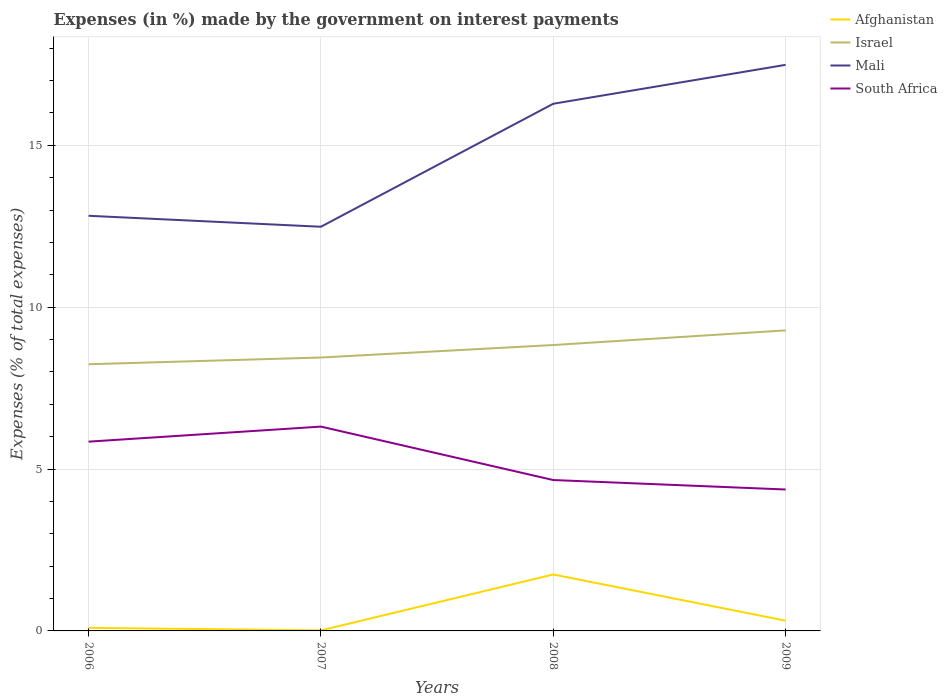Does the line corresponding to Mali intersect with the line corresponding to Israel?
Offer a terse response. No. Is the number of lines equal to the number of legend labels?
Provide a short and direct response. Yes. Across all years, what is the maximum percentage of expenses made by the government on interest payments in Afghanistan?
Offer a very short reply. 0.02. In which year was the percentage of expenses made by the government on interest payments in Israel maximum?
Your response must be concise. 2006. What is the total percentage of expenses made by the government on interest payments in South Africa in the graph?
Offer a terse response. 1.48. What is the difference between the highest and the second highest percentage of expenses made by the government on interest payments in South Africa?
Keep it short and to the point. 1.94. What is the difference between the highest and the lowest percentage of expenses made by the government on interest payments in Mali?
Keep it short and to the point. 2. Is the percentage of expenses made by the government on interest payments in Israel strictly greater than the percentage of expenses made by the government on interest payments in Afghanistan over the years?
Your answer should be very brief. No. How many lines are there?
Ensure brevity in your answer.  4. How many years are there in the graph?
Offer a very short reply. 4. What is the difference between two consecutive major ticks on the Y-axis?
Ensure brevity in your answer.  5. Are the values on the major ticks of Y-axis written in scientific E-notation?
Give a very brief answer. No. Does the graph contain grids?
Provide a succinct answer. Yes. Where does the legend appear in the graph?
Offer a very short reply. Top right. What is the title of the graph?
Ensure brevity in your answer.  Expenses (in %) made by the government on interest payments. Does "Andorra" appear as one of the legend labels in the graph?
Give a very brief answer. No. What is the label or title of the X-axis?
Your answer should be very brief. Years. What is the label or title of the Y-axis?
Offer a very short reply. Expenses (% of total expenses). What is the Expenses (% of total expenses) of Afghanistan in 2006?
Your answer should be very brief. 0.1. What is the Expenses (% of total expenses) of Israel in 2006?
Ensure brevity in your answer.  8.24. What is the Expenses (% of total expenses) of Mali in 2006?
Ensure brevity in your answer.  12.82. What is the Expenses (% of total expenses) of South Africa in 2006?
Your answer should be very brief. 5.85. What is the Expenses (% of total expenses) of Afghanistan in 2007?
Give a very brief answer. 0.02. What is the Expenses (% of total expenses) of Israel in 2007?
Your response must be concise. 8.45. What is the Expenses (% of total expenses) of Mali in 2007?
Ensure brevity in your answer.  12.49. What is the Expenses (% of total expenses) of South Africa in 2007?
Provide a short and direct response. 6.31. What is the Expenses (% of total expenses) of Afghanistan in 2008?
Provide a succinct answer. 1.74. What is the Expenses (% of total expenses) in Israel in 2008?
Your answer should be very brief. 8.83. What is the Expenses (% of total expenses) in Mali in 2008?
Provide a succinct answer. 16.28. What is the Expenses (% of total expenses) of South Africa in 2008?
Your response must be concise. 4.66. What is the Expenses (% of total expenses) of Afghanistan in 2009?
Keep it short and to the point. 0.32. What is the Expenses (% of total expenses) of Israel in 2009?
Your response must be concise. 9.28. What is the Expenses (% of total expenses) in Mali in 2009?
Your answer should be very brief. 17.49. What is the Expenses (% of total expenses) of South Africa in 2009?
Provide a short and direct response. 4.37. Across all years, what is the maximum Expenses (% of total expenses) of Afghanistan?
Your answer should be compact. 1.74. Across all years, what is the maximum Expenses (% of total expenses) in Israel?
Make the answer very short. 9.28. Across all years, what is the maximum Expenses (% of total expenses) of Mali?
Ensure brevity in your answer.  17.49. Across all years, what is the maximum Expenses (% of total expenses) in South Africa?
Your answer should be compact. 6.31. Across all years, what is the minimum Expenses (% of total expenses) in Afghanistan?
Make the answer very short. 0.02. Across all years, what is the minimum Expenses (% of total expenses) of Israel?
Your answer should be compact. 8.24. Across all years, what is the minimum Expenses (% of total expenses) of Mali?
Keep it short and to the point. 12.49. Across all years, what is the minimum Expenses (% of total expenses) of South Africa?
Provide a succinct answer. 4.37. What is the total Expenses (% of total expenses) of Afghanistan in the graph?
Provide a succinct answer. 2.17. What is the total Expenses (% of total expenses) of Israel in the graph?
Your response must be concise. 34.8. What is the total Expenses (% of total expenses) in Mali in the graph?
Keep it short and to the point. 59.08. What is the total Expenses (% of total expenses) of South Africa in the graph?
Make the answer very short. 21.19. What is the difference between the Expenses (% of total expenses) of Afghanistan in 2006 and that in 2007?
Your answer should be compact. 0.08. What is the difference between the Expenses (% of total expenses) of Israel in 2006 and that in 2007?
Your response must be concise. -0.21. What is the difference between the Expenses (% of total expenses) of Mali in 2006 and that in 2007?
Offer a very short reply. 0.34. What is the difference between the Expenses (% of total expenses) in South Africa in 2006 and that in 2007?
Your answer should be very brief. -0.47. What is the difference between the Expenses (% of total expenses) of Afghanistan in 2006 and that in 2008?
Offer a very short reply. -1.65. What is the difference between the Expenses (% of total expenses) in Israel in 2006 and that in 2008?
Offer a terse response. -0.59. What is the difference between the Expenses (% of total expenses) of Mali in 2006 and that in 2008?
Your answer should be compact. -3.46. What is the difference between the Expenses (% of total expenses) of South Africa in 2006 and that in 2008?
Give a very brief answer. 1.19. What is the difference between the Expenses (% of total expenses) in Afghanistan in 2006 and that in 2009?
Ensure brevity in your answer.  -0.22. What is the difference between the Expenses (% of total expenses) in Israel in 2006 and that in 2009?
Give a very brief answer. -1.05. What is the difference between the Expenses (% of total expenses) in Mali in 2006 and that in 2009?
Provide a short and direct response. -4.66. What is the difference between the Expenses (% of total expenses) in South Africa in 2006 and that in 2009?
Keep it short and to the point. 1.48. What is the difference between the Expenses (% of total expenses) of Afghanistan in 2007 and that in 2008?
Make the answer very short. -1.73. What is the difference between the Expenses (% of total expenses) of Israel in 2007 and that in 2008?
Ensure brevity in your answer.  -0.39. What is the difference between the Expenses (% of total expenses) of Mali in 2007 and that in 2008?
Your response must be concise. -3.8. What is the difference between the Expenses (% of total expenses) of South Africa in 2007 and that in 2008?
Offer a terse response. 1.65. What is the difference between the Expenses (% of total expenses) of Afghanistan in 2007 and that in 2009?
Your answer should be compact. -0.3. What is the difference between the Expenses (% of total expenses) in Israel in 2007 and that in 2009?
Provide a short and direct response. -0.84. What is the difference between the Expenses (% of total expenses) in Mali in 2007 and that in 2009?
Offer a terse response. -5. What is the difference between the Expenses (% of total expenses) in South Africa in 2007 and that in 2009?
Your response must be concise. 1.94. What is the difference between the Expenses (% of total expenses) in Afghanistan in 2008 and that in 2009?
Provide a short and direct response. 1.43. What is the difference between the Expenses (% of total expenses) in Israel in 2008 and that in 2009?
Your response must be concise. -0.45. What is the difference between the Expenses (% of total expenses) in Mali in 2008 and that in 2009?
Your answer should be compact. -1.2. What is the difference between the Expenses (% of total expenses) of South Africa in 2008 and that in 2009?
Ensure brevity in your answer.  0.29. What is the difference between the Expenses (% of total expenses) in Afghanistan in 2006 and the Expenses (% of total expenses) in Israel in 2007?
Make the answer very short. -8.35. What is the difference between the Expenses (% of total expenses) of Afghanistan in 2006 and the Expenses (% of total expenses) of Mali in 2007?
Ensure brevity in your answer.  -12.39. What is the difference between the Expenses (% of total expenses) of Afghanistan in 2006 and the Expenses (% of total expenses) of South Africa in 2007?
Offer a very short reply. -6.22. What is the difference between the Expenses (% of total expenses) in Israel in 2006 and the Expenses (% of total expenses) in Mali in 2007?
Make the answer very short. -4.25. What is the difference between the Expenses (% of total expenses) in Israel in 2006 and the Expenses (% of total expenses) in South Africa in 2007?
Your answer should be compact. 1.93. What is the difference between the Expenses (% of total expenses) of Mali in 2006 and the Expenses (% of total expenses) of South Africa in 2007?
Give a very brief answer. 6.51. What is the difference between the Expenses (% of total expenses) of Afghanistan in 2006 and the Expenses (% of total expenses) of Israel in 2008?
Your answer should be very brief. -8.74. What is the difference between the Expenses (% of total expenses) in Afghanistan in 2006 and the Expenses (% of total expenses) in Mali in 2008?
Keep it short and to the point. -16.19. What is the difference between the Expenses (% of total expenses) of Afghanistan in 2006 and the Expenses (% of total expenses) of South Africa in 2008?
Your response must be concise. -4.57. What is the difference between the Expenses (% of total expenses) of Israel in 2006 and the Expenses (% of total expenses) of Mali in 2008?
Your answer should be compact. -8.05. What is the difference between the Expenses (% of total expenses) of Israel in 2006 and the Expenses (% of total expenses) of South Africa in 2008?
Your answer should be very brief. 3.58. What is the difference between the Expenses (% of total expenses) in Mali in 2006 and the Expenses (% of total expenses) in South Africa in 2008?
Give a very brief answer. 8.16. What is the difference between the Expenses (% of total expenses) of Afghanistan in 2006 and the Expenses (% of total expenses) of Israel in 2009?
Offer a very short reply. -9.19. What is the difference between the Expenses (% of total expenses) in Afghanistan in 2006 and the Expenses (% of total expenses) in Mali in 2009?
Ensure brevity in your answer.  -17.39. What is the difference between the Expenses (% of total expenses) in Afghanistan in 2006 and the Expenses (% of total expenses) in South Africa in 2009?
Keep it short and to the point. -4.27. What is the difference between the Expenses (% of total expenses) of Israel in 2006 and the Expenses (% of total expenses) of Mali in 2009?
Provide a succinct answer. -9.25. What is the difference between the Expenses (% of total expenses) of Israel in 2006 and the Expenses (% of total expenses) of South Africa in 2009?
Offer a very short reply. 3.87. What is the difference between the Expenses (% of total expenses) in Mali in 2006 and the Expenses (% of total expenses) in South Africa in 2009?
Keep it short and to the point. 8.46. What is the difference between the Expenses (% of total expenses) of Afghanistan in 2007 and the Expenses (% of total expenses) of Israel in 2008?
Your answer should be very brief. -8.82. What is the difference between the Expenses (% of total expenses) of Afghanistan in 2007 and the Expenses (% of total expenses) of Mali in 2008?
Give a very brief answer. -16.27. What is the difference between the Expenses (% of total expenses) in Afghanistan in 2007 and the Expenses (% of total expenses) in South Africa in 2008?
Your answer should be very brief. -4.64. What is the difference between the Expenses (% of total expenses) of Israel in 2007 and the Expenses (% of total expenses) of Mali in 2008?
Keep it short and to the point. -7.84. What is the difference between the Expenses (% of total expenses) of Israel in 2007 and the Expenses (% of total expenses) of South Africa in 2008?
Keep it short and to the point. 3.78. What is the difference between the Expenses (% of total expenses) in Mali in 2007 and the Expenses (% of total expenses) in South Africa in 2008?
Offer a very short reply. 7.82. What is the difference between the Expenses (% of total expenses) in Afghanistan in 2007 and the Expenses (% of total expenses) in Israel in 2009?
Your answer should be very brief. -9.27. What is the difference between the Expenses (% of total expenses) of Afghanistan in 2007 and the Expenses (% of total expenses) of Mali in 2009?
Offer a very short reply. -17.47. What is the difference between the Expenses (% of total expenses) in Afghanistan in 2007 and the Expenses (% of total expenses) in South Africa in 2009?
Make the answer very short. -4.35. What is the difference between the Expenses (% of total expenses) in Israel in 2007 and the Expenses (% of total expenses) in Mali in 2009?
Keep it short and to the point. -9.04. What is the difference between the Expenses (% of total expenses) in Israel in 2007 and the Expenses (% of total expenses) in South Africa in 2009?
Provide a short and direct response. 4.08. What is the difference between the Expenses (% of total expenses) of Mali in 2007 and the Expenses (% of total expenses) of South Africa in 2009?
Keep it short and to the point. 8.12. What is the difference between the Expenses (% of total expenses) in Afghanistan in 2008 and the Expenses (% of total expenses) in Israel in 2009?
Provide a short and direct response. -7.54. What is the difference between the Expenses (% of total expenses) in Afghanistan in 2008 and the Expenses (% of total expenses) in Mali in 2009?
Offer a terse response. -15.74. What is the difference between the Expenses (% of total expenses) of Afghanistan in 2008 and the Expenses (% of total expenses) of South Africa in 2009?
Ensure brevity in your answer.  -2.63. What is the difference between the Expenses (% of total expenses) of Israel in 2008 and the Expenses (% of total expenses) of Mali in 2009?
Your response must be concise. -8.66. What is the difference between the Expenses (% of total expenses) of Israel in 2008 and the Expenses (% of total expenses) of South Africa in 2009?
Provide a succinct answer. 4.46. What is the difference between the Expenses (% of total expenses) of Mali in 2008 and the Expenses (% of total expenses) of South Africa in 2009?
Make the answer very short. 11.92. What is the average Expenses (% of total expenses) in Afghanistan per year?
Your response must be concise. 0.54. What is the average Expenses (% of total expenses) in Israel per year?
Make the answer very short. 8.7. What is the average Expenses (% of total expenses) in Mali per year?
Ensure brevity in your answer.  14.77. What is the average Expenses (% of total expenses) in South Africa per year?
Offer a very short reply. 5.3. In the year 2006, what is the difference between the Expenses (% of total expenses) in Afghanistan and Expenses (% of total expenses) in Israel?
Offer a terse response. -8.14. In the year 2006, what is the difference between the Expenses (% of total expenses) of Afghanistan and Expenses (% of total expenses) of Mali?
Provide a succinct answer. -12.73. In the year 2006, what is the difference between the Expenses (% of total expenses) in Afghanistan and Expenses (% of total expenses) in South Africa?
Offer a terse response. -5.75. In the year 2006, what is the difference between the Expenses (% of total expenses) of Israel and Expenses (% of total expenses) of Mali?
Keep it short and to the point. -4.59. In the year 2006, what is the difference between the Expenses (% of total expenses) of Israel and Expenses (% of total expenses) of South Africa?
Offer a terse response. 2.39. In the year 2006, what is the difference between the Expenses (% of total expenses) in Mali and Expenses (% of total expenses) in South Africa?
Offer a very short reply. 6.98. In the year 2007, what is the difference between the Expenses (% of total expenses) of Afghanistan and Expenses (% of total expenses) of Israel?
Your response must be concise. -8.43. In the year 2007, what is the difference between the Expenses (% of total expenses) of Afghanistan and Expenses (% of total expenses) of Mali?
Ensure brevity in your answer.  -12.47. In the year 2007, what is the difference between the Expenses (% of total expenses) in Afghanistan and Expenses (% of total expenses) in South Africa?
Ensure brevity in your answer.  -6.3. In the year 2007, what is the difference between the Expenses (% of total expenses) in Israel and Expenses (% of total expenses) in Mali?
Ensure brevity in your answer.  -4.04. In the year 2007, what is the difference between the Expenses (% of total expenses) in Israel and Expenses (% of total expenses) in South Africa?
Give a very brief answer. 2.13. In the year 2007, what is the difference between the Expenses (% of total expenses) of Mali and Expenses (% of total expenses) of South Africa?
Ensure brevity in your answer.  6.17. In the year 2008, what is the difference between the Expenses (% of total expenses) in Afghanistan and Expenses (% of total expenses) in Israel?
Your response must be concise. -7.09. In the year 2008, what is the difference between the Expenses (% of total expenses) of Afghanistan and Expenses (% of total expenses) of Mali?
Your response must be concise. -14.54. In the year 2008, what is the difference between the Expenses (% of total expenses) of Afghanistan and Expenses (% of total expenses) of South Africa?
Ensure brevity in your answer.  -2.92. In the year 2008, what is the difference between the Expenses (% of total expenses) of Israel and Expenses (% of total expenses) of Mali?
Offer a terse response. -7.45. In the year 2008, what is the difference between the Expenses (% of total expenses) of Israel and Expenses (% of total expenses) of South Africa?
Your answer should be very brief. 4.17. In the year 2008, what is the difference between the Expenses (% of total expenses) in Mali and Expenses (% of total expenses) in South Africa?
Ensure brevity in your answer.  11.62. In the year 2009, what is the difference between the Expenses (% of total expenses) of Afghanistan and Expenses (% of total expenses) of Israel?
Make the answer very short. -8.97. In the year 2009, what is the difference between the Expenses (% of total expenses) of Afghanistan and Expenses (% of total expenses) of Mali?
Offer a very short reply. -17.17. In the year 2009, what is the difference between the Expenses (% of total expenses) in Afghanistan and Expenses (% of total expenses) in South Africa?
Offer a very short reply. -4.05. In the year 2009, what is the difference between the Expenses (% of total expenses) of Israel and Expenses (% of total expenses) of Mali?
Make the answer very short. -8.2. In the year 2009, what is the difference between the Expenses (% of total expenses) in Israel and Expenses (% of total expenses) in South Africa?
Your response must be concise. 4.92. In the year 2009, what is the difference between the Expenses (% of total expenses) in Mali and Expenses (% of total expenses) in South Africa?
Keep it short and to the point. 13.12. What is the ratio of the Expenses (% of total expenses) in Afghanistan in 2006 to that in 2007?
Your answer should be compact. 5.95. What is the ratio of the Expenses (% of total expenses) of Israel in 2006 to that in 2007?
Offer a very short reply. 0.98. What is the ratio of the Expenses (% of total expenses) of Mali in 2006 to that in 2007?
Keep it short and to the point. 1.03. What is the ratio of the Expenses (% of total expenses) of South Africa in 2006 to that in 2007?
Make the answer very short. 0.93. What is the ratio of the Expenses (% of total expenses) in Afghanistan in 2006 to that in 2008?
Offer a terse response. 0.05. What is the ratio of the Expenses (% of total expenses) in Israel in 2006 to that in 2008?
Your response must be concise. 0.93. What is the ratio of the Expenses (% of total expenses) in Mali in 2006 to that in 2008?
Give a very brief answer. 0.79. What is the ratio of the Expenses (% of total expenses) in South Africa in 2006 to that in 2008?
Ensure brevity in your answer.  1.25. What is the ratio of the Expenses (% of total expenses) in Afghanistan in 2006 to that in 2009?
Provide a succinct answer. 0.3. What is the ratio of the Expenses (% of total expenses) of Israel in 2006 to that in 2009?
Your answer should be compact. 0.89. What is the ratio of the Expenses (% of total expenses) in Mali in 2006 to that in 2009?
Provide a short and direct response. 0.73. What is the ratio of the Expenses (% of total expenses) of South Africa in 2006 to that in 2009?
Offer a terse response. 1.34. What is the ratio of the Expenses (% of total expenses) in Afghanistan in 2007 to that in 2008?
Your answer should be compact. 0.01. What is the ratio of the Expenses (% of total expenses) of Israel in 2007 to that in 2008?
Offer a terse response. 0.96. What is the ratio of the Expenses (% of total expenses) in Mali in 2007 to that in 2008?
Provide a succinct answer. 0.77. What is the ratio of the Expenses (% of total expenses) in South Africa in 2007 to that in 2008?
Give a very brief answer. 1.35. What is the ratio of the Expenses (% of total expenses) of Afghanistan in 2007 to that in 2009?
Keep it short and to the point. 0.05. What is the ratio of the Expenses (% of total expenses) of Israel in 2007 to that in 2009?
Keep it short and to the point. 0.91. What is the ratio of the Expenses (% of total expenses) of Mali in 2007 to that in 2009?
Give a very brief answer. 0.71. What is the ratio of the Expenses (% of total expenses) of South Africa in 2007 to that in 2009?
Provide a short and direct response. 1.44. What is the ratio of the Expenses (% of total expenses) in Afghanistan in 2008 to that in 2009?
Ensure brevity in your answer.  5.51. What is the ratio of the Expenses (% of total expenses) of Israel in 2008 to that in 2009?
Your response must be concise. 0.95. What is the ratio of the Expenses (% of total expenses) in Mali in 2008 to that in 2009?
Provide a succinct answer. 0.93. What is the ratio of the Expenses (% of total expenses) in South Africa in 2008 to that in 2009?
Your answer should be compact. 1.07. What is the difference between the highest and the second highest Expenses (% of total expenses) in Afghanistan?
Provide a short and direct response. 1.43. What is the difference between the highest and the second highest Expenses (% of total expenses) in Israel?
Provide a short and direct response. 0.45. What is the difference between the highest and the second highest Expenses (% of total expenses) in Mali?
Your answer should be compact. 1.2. What is the difference between the highest and the second highest Expenses (% of total expenses) in South Africa?
Provide a succinct answer. 0.47. What is the difference between the highest and the lowest Expenses (% of total expenses) of Afghanistan?
Provide a short and direct response. 1.73. What is the difference between the highest and the lowest Expenses (% of total expenses) of Israel?
Provide a succinct answer. 1.05. What is the difference between the highest and the lowest Expenses (% of total expenses) in Mali?
Provide a short and direct response. 5. What is the difference between the highest and the lowest Expenses (% of total expenses) of South Africa?
Offer a very short reply. 1.94. 